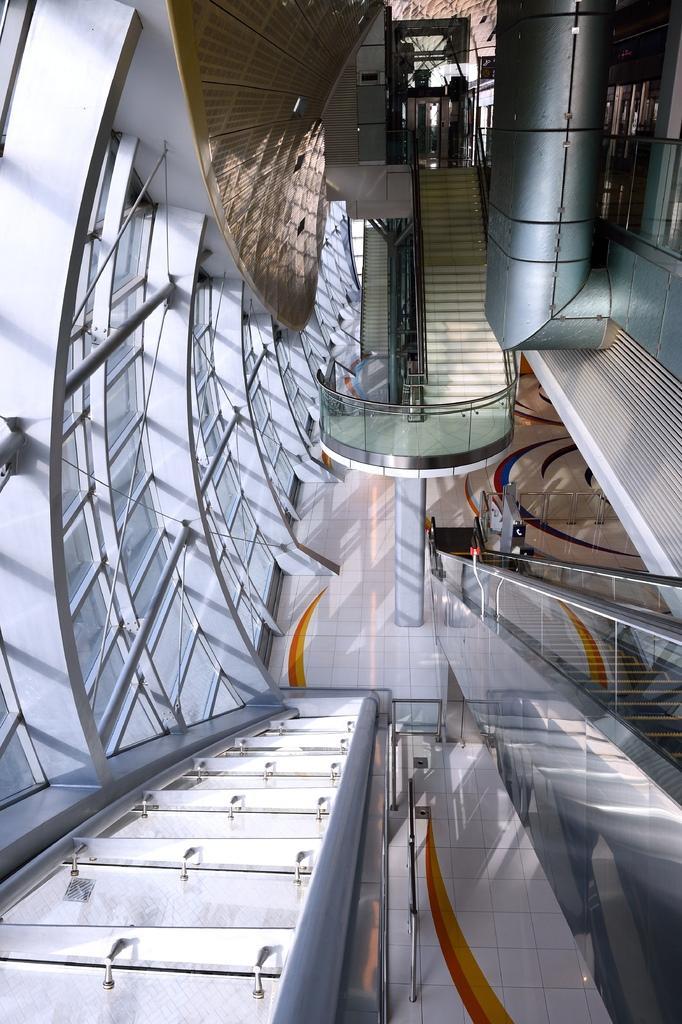Please provide a concise description of this image. In this image e can see inside view of a mall in which there are some stairs, escalator, lift and some glass windows. 